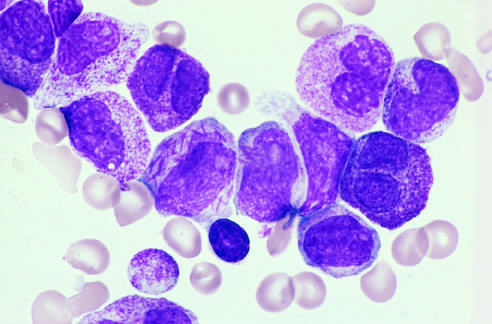what has abnormally coarse and numerous azurophilic granules?
Answer the question using a single word or phrase. Neo-plastic promyelocytes 